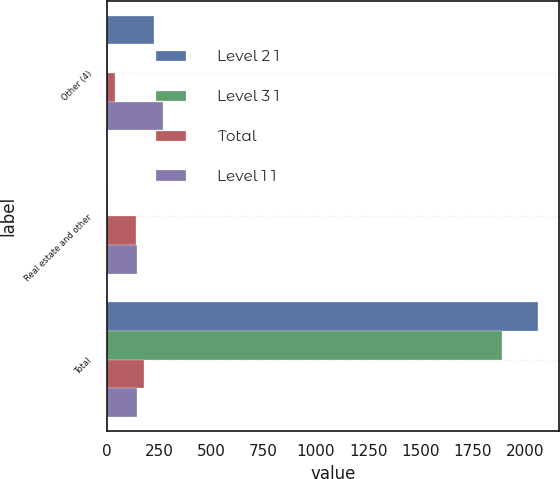Convert chart to OTSL. <chart><loc_0><loc_0><loc_500><loc_500><stacked_bar_chart><ecel><fcel>Other (4)<fcel>Real estate and other<fcel>Total<nl><fcel>Level 2 1<fcel>225<fcel>1<fcel>2060<nl><fcel>Level 3 1<fcel>7<fcel>7<fcel>1889<nl><fcel>Total<fcel>39<fcel>139<fcel>178<nl><fcel>Level 1 1<fcel>271<fcel>147<fcel>147<nl></chart> 